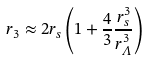<formula> <loc_0><loc_0><loc_500><loc_500>r _ { 3 } \approx 2 r _ { s } \left ( 1 + \frac { 4 } { 3 } \frac { r _ { s } ^ { 3 } } { r _ { \varLambda } ^ { 3 } } \right )</formula> 